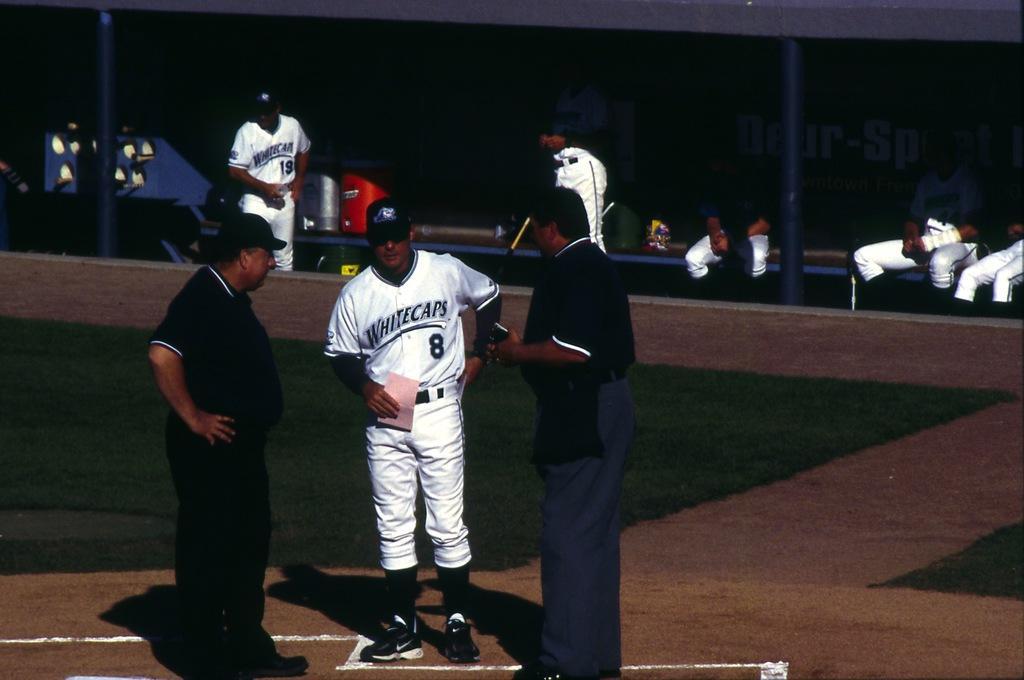Describe this image in one or two sentences. In the picture we can see a playground on it, we can see three people are standing, one man is in sports wear and behind them, we can see a green color mat and on it also we can see two men are standing in sports wear and behind them we can see a bench on it we can see some things are placed. 